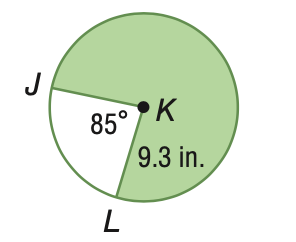Question: Find the area of the shaded sector. Round to the nearest tenth.
Choices:
A. 44.6
B. 64.2
C. 103.8
D. 207.6
Answer with the letter. Answer: D 